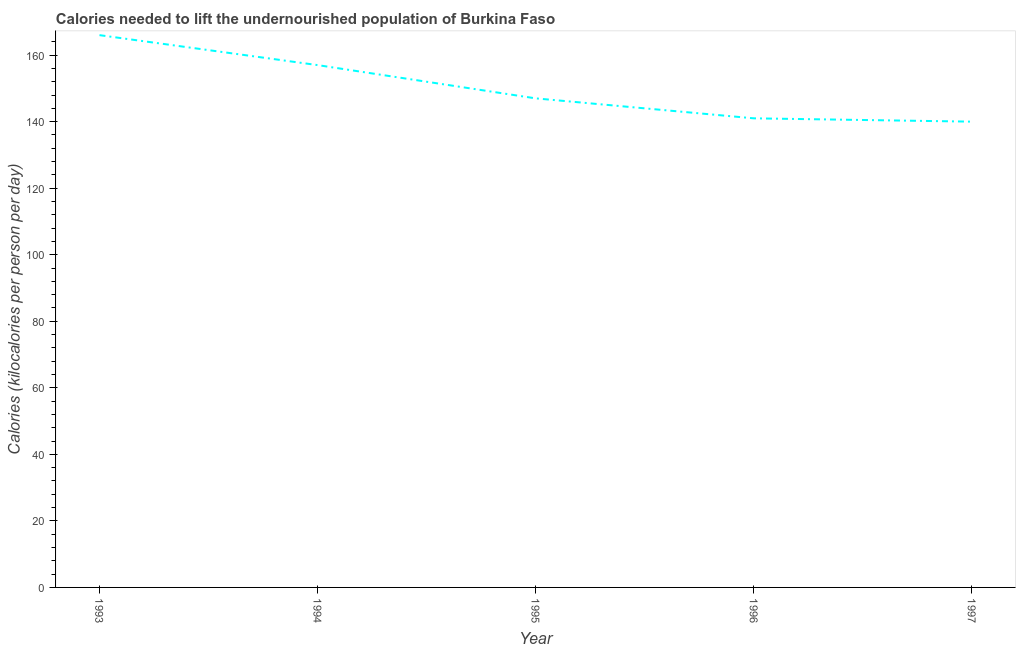What is the depth of food deficit in 1997?
Provide a succinct answer. 140. Across all years, what is the maximum depth of food deficit?
Keep it short and to the point. 166. Across all years, what is the minimum depth of food deficit?
Make the answer very short. 140. What is the sum of the depth of food deficit?
Keep it short and to the point. 751. What is the difference between the depth of food deficit in 1994 and 1996?
Ensure brevity in your answer.  16. What is the average depth of food deficit per year?
Your response must be concise. 150.2. What is the median depth of food deficit?
Offer a terse response. 147. In how many years, is the depth of food deficit greater than 36 kilocalories?
Keep it short and to the point. 5. What is the ratio of the depth of food deficit in 1993 to that in 1995?
Give a very brief answer. 1.13. Is the difference between the depth of food deficit in 1994 and 1997 greater than the difference between any two years?
Your answer should be compact. No. Is the sum of the depth of food deficit in 1993 and 1995 greater than the maximum depth of food deficit across all years?
Keep it short and to the point. Yes. What is the difference between the highest and the lowest depth of food deficit?
Your response must be concise. 26. Does the depth of food deficit monotonically increase over the years?
Ensure brevity in your answer.  No. What is the difference between two consecutive major ticks on the Y-axis?
Give a very brief answer. 20. Are the values on the major ticks of Y-axis written in scientific E-notation?
Offer a very short reply. No. Does the graph contain grids?
Give a very brief answer. No. What is the title of the graph?
Offer a terse response. Calories needed to lift the undernourished population of Burkina Faso. What is the label or title of the X-axis?
Provide a short and direct response. Year. What is the label or title of the Y-axis?
Provide a succinct answer. Calories (kilocalories per person per day). What is the Calories (kilocalories per person per day) in 1993?
Provide a short and direct response. 166. What is the Calories (kilocalories per person per day) in 1994?
Your answer should be compact. 157. What is the Calories (kilocalories per person per day) in 1995?
Give a very brief answer. 147. What is the Calories (kilocalories per person per day) of 1996?
Make the answer very short. 141. What is the Calories (kilocalories per person per day) in 1997?
Your answer should be compact. 140. What is the difference between the Calories (kilocalories per person per day) in 1993 and 1994?
Offer a terse response. 9. What is the difference between the Calories (kilocalories per person per day) in 1993 and 1995?
Your answer should be very brief. 19. What is the difference between the Calories (kilocalories per person per day) in 1993 and 1996?
Keep it short and to the point. 25. What is the difference between the Calories (kilocalories per person per day) in 1993 and 1997?
Provide a short and direct response. 26. What is the difference between the Calories (kilocalories per person per day) in 1994 and 1995?
Your answer should be very brief. 10. What is the difference between the Calories (kilocalories per person per day) in 1994 and 1996?
Your response must be concise. 16. What is the difference between the Calories (kilocalories per person per day) in 1994 and 1997?
Provide a succinct answer. 17. What is the difference between the Calories (kilocalories per person per day) in 1995 and 1996?
Offer a very short reply. 6. What is the difference between the Calories (kilocalories per person per day) in 1996 and 1997?
Provide a short and direct response. 1. What is the ratio of the Calories (kilocalories per person per day) in 1993 to that in 1994?
Your answer should be very brief. 1.06. What is the ratio of the Calories (kilocalories per person per day) in 1993 to that in 1995?
Give a very brief answer. 1.13. What is the ratio of the Calories (kilocalories per person per day) in 1993 to that in 1996?
Your response must be concise. 1.18. What is the ratio of the Calories (kilocalories per person per day) in 1993 to that in 1997?
Your answer should be very brief. 1.19. What is the ratio of the Calories (kilocalories per person per day) in 1994 to that in 1995?
Keep it short and to the point. 1.07. What is the ratio of the Calories (kilocalories per person per day) in 1994 to that in 1996?
Ensure brevity in your answer.  1.11. What is the ratio of the Calories (kilocalories per person per day) in 1994 to that in 1997?
Your response must be concise. 1.12. What is the ratio of the Calories (kilocalories per person per day) in 1995 to that in 1996?
Make the answer very short. 1.04. What is the ratio of the Calories (kilocalories per person per day) in 1996 to that in 1997?
Provide a succinct answer. 1.01. 